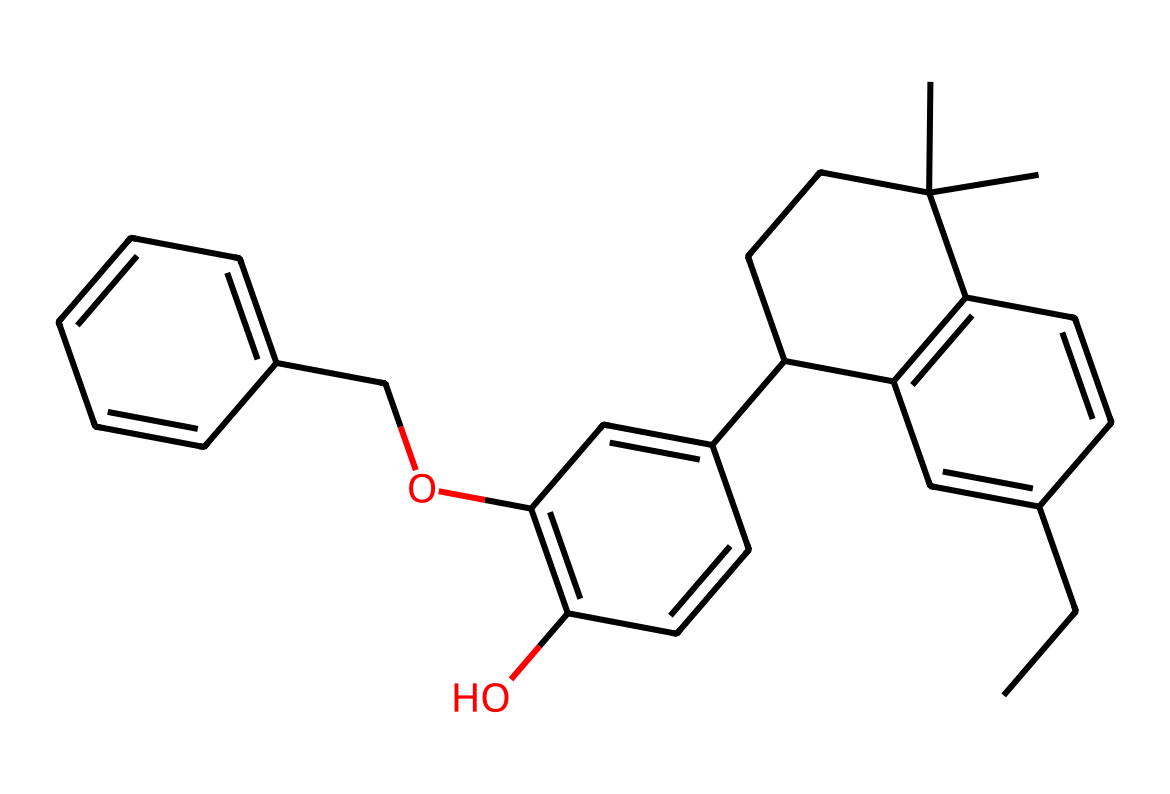What is the molecular formula of this compound? To determine the molecular formula from the SMILES representation, we first interpret the structure. The atoms present can be counted and organized: C (carbon), H (hydrogen), and O (oxygen). After analyzing the structure, we find there are 27 carbon atoms, 34 hydrogen atoms, and 4 oxygen atoms, leading us to the molecular formula C27H34O4.
Answer: C27H34O4 How many rings are present in the structure? By examining the SMILES string, we can identify the rings by looking for the numbers that indicate ring closures. There are two ring systems indicated by the '1' and '2' markers in the SMILES, suggesting that there are two distinct cyclic structures. Thus, the total number of rings is two.
Answer: 2 What functional groups can be identified in this chemical? The chemical structure contains hydroxyl groups (-OH) as shown by the presence of oxygen atoms bonded to carbons in the molecular structure. The presence of these functional groups indicates that the compound has properties associated with alcohols. Therefore, the main functional groups identifiable in this compound are two hydroxyl groups.
Answer: hydroxyl groups Is this compound likely hydrophilic or hydrophobic? The presence of hydroxyl groups in the chemical structure implies an affinity for water, as molecules with such groups tend to interact favorably with water due to hydrogen bonding. Thus, this compound is likely to be hydrophilic.
Answer: hydrophilic Does this compound have a chiral center? To assess chirality, we look for carbon atoms bonded to four different substituents. By reviewing the structure, we find carbon atoms that meet the criteria for chirality, thus confirming there are chiral centers in this compound.
Answer: yes What type of drug classification does this compound likely belong to? Given the presence of cannabidiol, which is a well-known cannabinoid, this compound can be classified as a cannabinoid. Cannabinoids are typically classified based on their interaction with the endocannabinoid system. Therefore, the classification reflects its source and biological application in wellness.
Answer: cannabinoid 